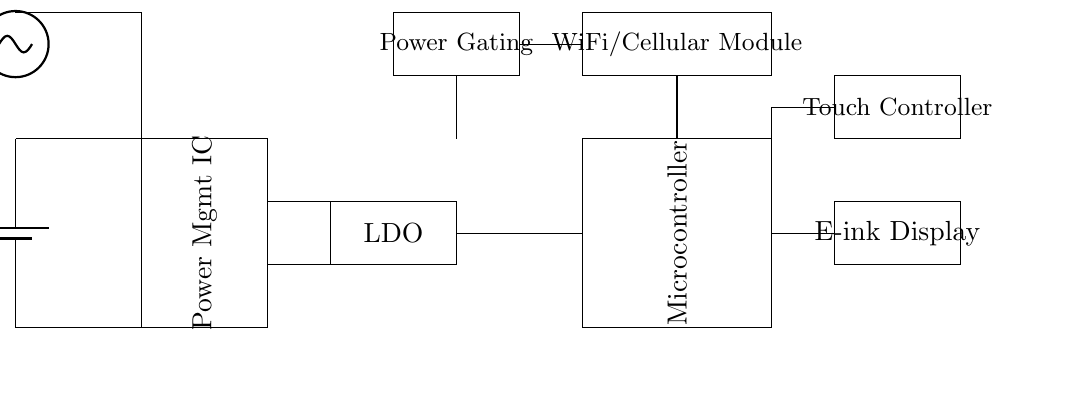What is the voltage of the battery? The battery in the circuit is labeled with a voltage of 3.7 volts, indicating this is the potential difference provided by it.
Answer: 3.7 volts What is the purpose of the power management integrated circuit? The power management IC is responsible for regulating and optimizing the power usage of the device, ensuring efficient energy distribution across components.
Answer: Power management What type of display is used in this circuit? The circuit diagram specifies the use of an E-ink display, which is known for its low power consumption and readability in various lighting conditions.
Answer: E-ink Display How does the solar panel connect to the circuit? The solar panel is connected directly to the battery and the power management IC, providing additional energy when exposed to sunlight, thereby enhancing battery life.
Answer: Directly to battery What is the role of the low-dropout regulator? The LDO's purpose is to provide a stable output voltage while minimizing energy loss, which is crucial for maintaining battery efficiency in mobile devices.
Answer: Voltage regulation Which component is responsible for enabling connectivity? The WiFi/Cellular module is responsible for connectivity, allowing the device to communicate wirelessly for mobile voting purposes.
Answer: WiFi/Cellular Module What energy-saving method is included in this circuit? The circuit incorporates power gating, which turns off power to unused components, helping to prolong battery life significantly.
Answer: Power Gating 